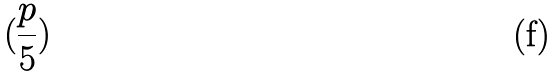Convert formula to latex. <formula><loc_0><loc_0><loc_500><loc_500>( \frac { p } { 5 } )</formula> 